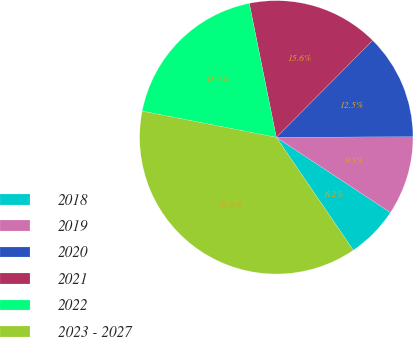Convert chart to OTSL. <chart><loc_0><loc_0><loc_500><loc_500><pie_chart><fcel>2018<fcel>2019<fcel>2020<fcel>2021<fcel>2022<fcel>2023 - 2027<nl><fcel>6.2%<fcel>9.34%<fcel>12.48%<fcel>15.62%<fcel>18.76%<fcel>37.59%<nl></chart> 